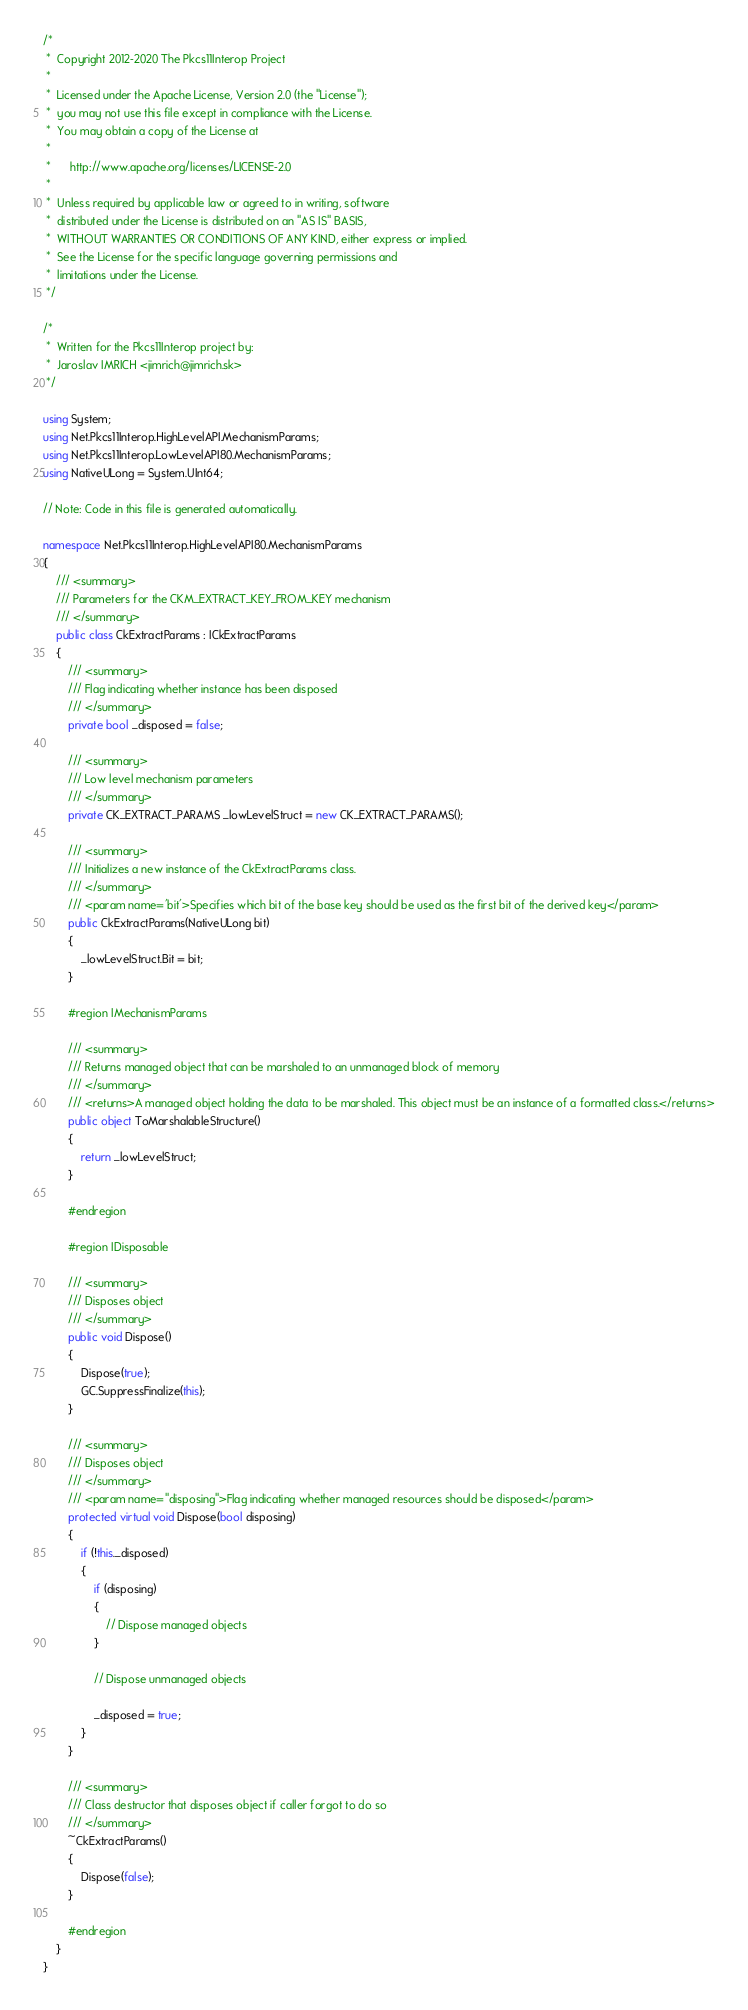<code> <loc_0><loc_0><loc_500><loc_500><_C#_>/*
 *  Copyright 2012-2020 The Pkcs11Interop Project
 *
 *  Licensed under the Apache License, Version 2.0 (the "License");
 *  you may not use this file except in compliance with the License.
 *  You may obtain a copy of the License at
 *
 *      http://www.apache.org/licenses/LICENSE-2.0
 *
 *  Unless required by applicable law or agreed to in writing, software
 *  distributed under the License is distributed on an "AS IS" BASIS,
 *  WITHOUT WARRANTIES OR CONDITIONS OF ANY KIND, either express or implied.
 *  See the License for the specific language governing permissions and
 *  limitations under the License.
 */

/*
 *  Written for the Pkcs11Interop project by:
 *  Jaroslav IMRICH <jimrich@jimrich.sk>
 */

using System;
using Net.Pkcs11Interop.HighLevelAPI.MechanismParams;
using Net.Pkcs11Interop.LowLevelAPI80.MechanismParams;
using NativeULong = System.UInt64;

// Note: Code in this file is generated automatically.

namespace Net.Pkcs11Interop.HighLevelAPI80.MechanismParams
{
    /// <summary>
    /// Parameters for the CKM_EXTRACT_KEY_FROM_KEY mechanism
    /// </summary>
    public class CkExtractParams : ICkExtractParams
    {
        /// <summary>
        /// Flag indicating whether instance has been disposed
        /// </summary>
        private bool _disposed = false;

        /// <summary>
        /// Low level mechanism parameters
        /// </summary>
        private CK_EXTRACT_PARAMS _lowLevelStruct = new CK_EXTRACT_PARAMS();

        /// <summary>
        /// Initializes a new instance of the CkExtractParams class.
        /// </summary>
        /// <param name='bit'>Specifies which bit of the base key should be used as the first bit of the derived key</param>
        public CkExtractParams(NativeULong bit)
        {
            _lowLevelStruct.Bit = bit;
        }
        
        #region IMechanismParams
        
        /// <summary>
        /// Returns managed object that can be marshaled to an unmanaged block of memory
        /// </summary>
        /// <returns>A managed object holding the data to be marshaled. This object must be an instance of a formatted class.</returns>
        public object ToMarshalableStructure()
        {
            return _lowLevelStruct;
        }

        #endregion

        #region IDisposable

        /// <summary>
        /// Disposes object
        /// </summary>
        public void Dispose()
        {
            Dispose(true);
            GC.SuppressFinalize(this);
        }

        /// <summary>
        /// Disposes object
        /// </summary>
        /// <param name="disposing">Flag indicating whether managed resources should be disposed</param>
        protected virtual void Dispose(bool disposing)
        {
            if (!this._disposed)
            {
                if (disposing)
                {
                    // Dispose managed objects
                }

                // Dispose unmanaged objects

                _disposed = true;
            }
        }

        /// <summary>
        /// Class destructor that disposes object if caller forgot to do so
        /// </summary>
        ~CkExtractParams()
        {
            Dispose(false);
        }

        #endregion
    }
}
</code> 